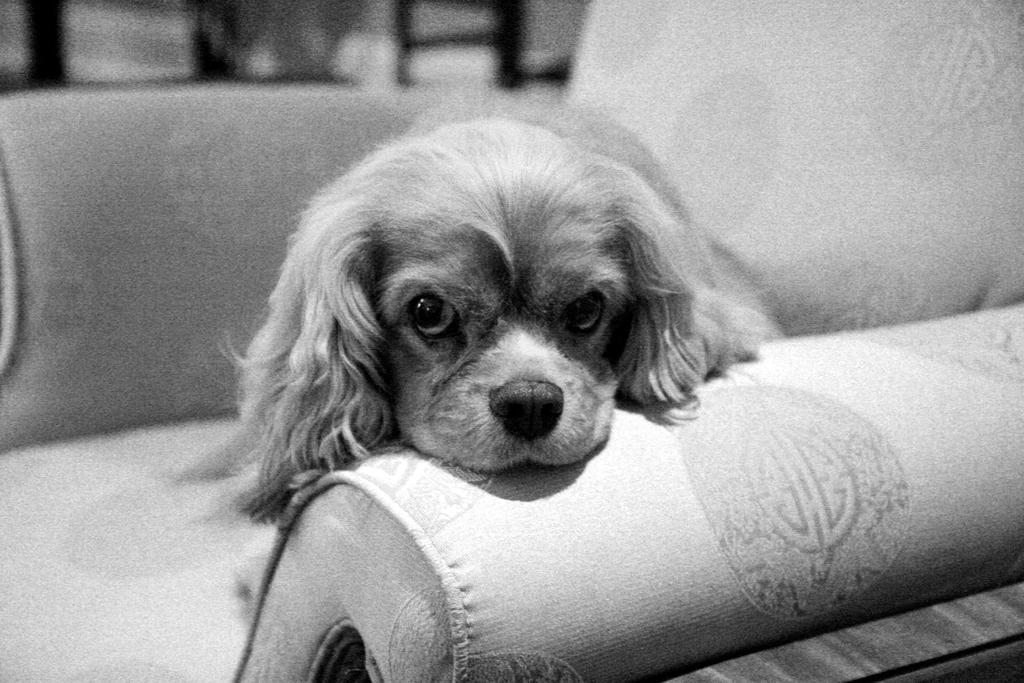What type of animal is in the image? There is a dog in the image. Where is the dog located? The dog is on a couch. What is the color scheme of the image? The image is black and white. What type of meal is the dog eating in the image? There is no meal present in the image; the dog is simply sitting on the couch. Can you tell me how many basketballs are visible in the image? There are no basketballs present in the image. 